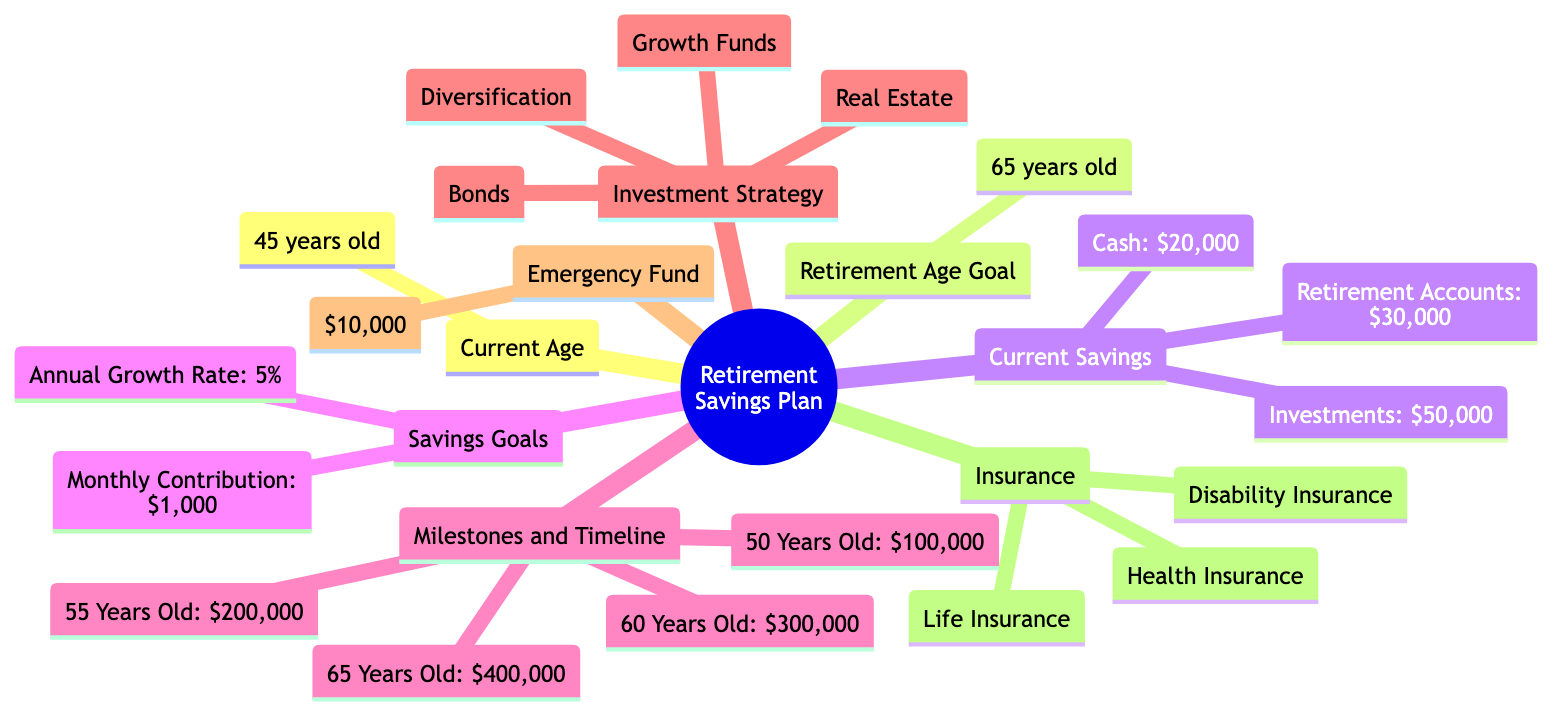What's the current age in the retirement plan? The diagram states that the current age is 45 years old, noted directly under the "Current Age" node.
Answer: 45 years old What is the target savings amount by age 55? According to the "Milestones and Timeline" section, the target savings amount by age 55 is $200,000.
Answer: $200,000 How much is the current investment portfolio value? Under "Current Savings," the diagram specifies that the value of current investments is $50,000.
Answer: $50,000 What is the monthly contribution towards retirement savings? The "Savings Goals" section indicates that the monthly contribution is $1,000.
Answer: $1,000 What should be the retirement savings target by age 60? The diagram shows that the target savings amount by age 60 is $300,000, found in the "Milestones and Timeline" section.
Answer: $300,000 How is the expected annual growth rate for investments expressed? Under "Savings Goals," the expected annual growth rate is stated as 5%, representing the growth percentage of the investments.
Answer: 5% What type of insurance is included in the retirement plan? The diagram mentions three types of insurance: health insurance, disability insurance, and life insurance, all found under the "Insurance" section.
Answer: Health Insurance, Disability Insurance, Life Insurance What is the cash savings amount available for retirement? The "Current Savings" section directly states that the cash savings amount is $20,000.
Answer: $20,000 What is the emergency fund value in the plan? The diagram notes that the emergency fund value is $10,000, located under the "Emergency Fund" section.
Answer: $10,000 